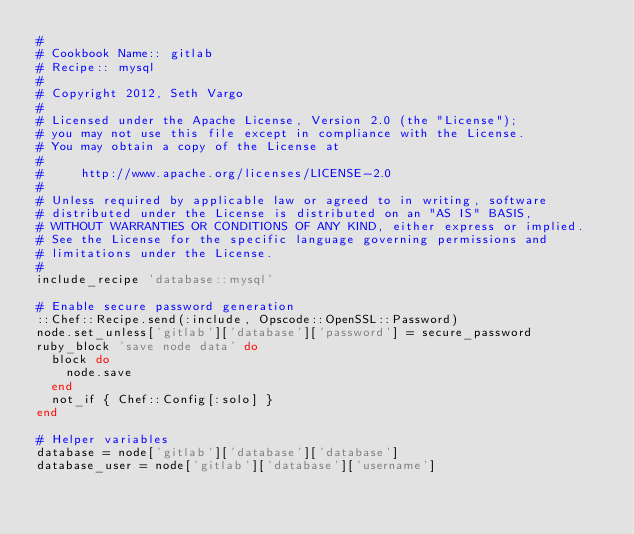<code> <loc_0><loc_0><loc_500><loc_500><_Ruby_>#
# Cookbook Name:: gitlab
# Recipe:: mysql
#
# Copyright 2012, Seth Vargo
#
# Licensed under the Apache License, Version 2.0 (the "License");
# you may not use this file except in compliance with the License.
# You may obtain a copy of the License at
#
#     http://www.apache.org/licenses/LICENSE-2.0
#
# Unless required by applicable law or agreed to in writing, software
# distributed under the License is distributed on an "AS IS" BASIS,
# WITHOUT WARRANTIES OR CONDITIONS OF ANY KIND, either express or implied.
# See the License for the specific language governing permissions and
# limitations under the License.
#
include_recipe 'database::mysql'

# Enable secure password generation
::Chef::Recipe.send(:include, Opscode::OpenSSL::Password)
node.set_unless['gitlab']['database']['password'] = secure_password
ruby_block 'save node data' do
  block do
    node.save
  end
  not_if { Chef::Config[:solo] }
end

# Helper variables
database = node['gitlab']['database']['database']
database_user = node['gitlab']['database']['username']</code> 